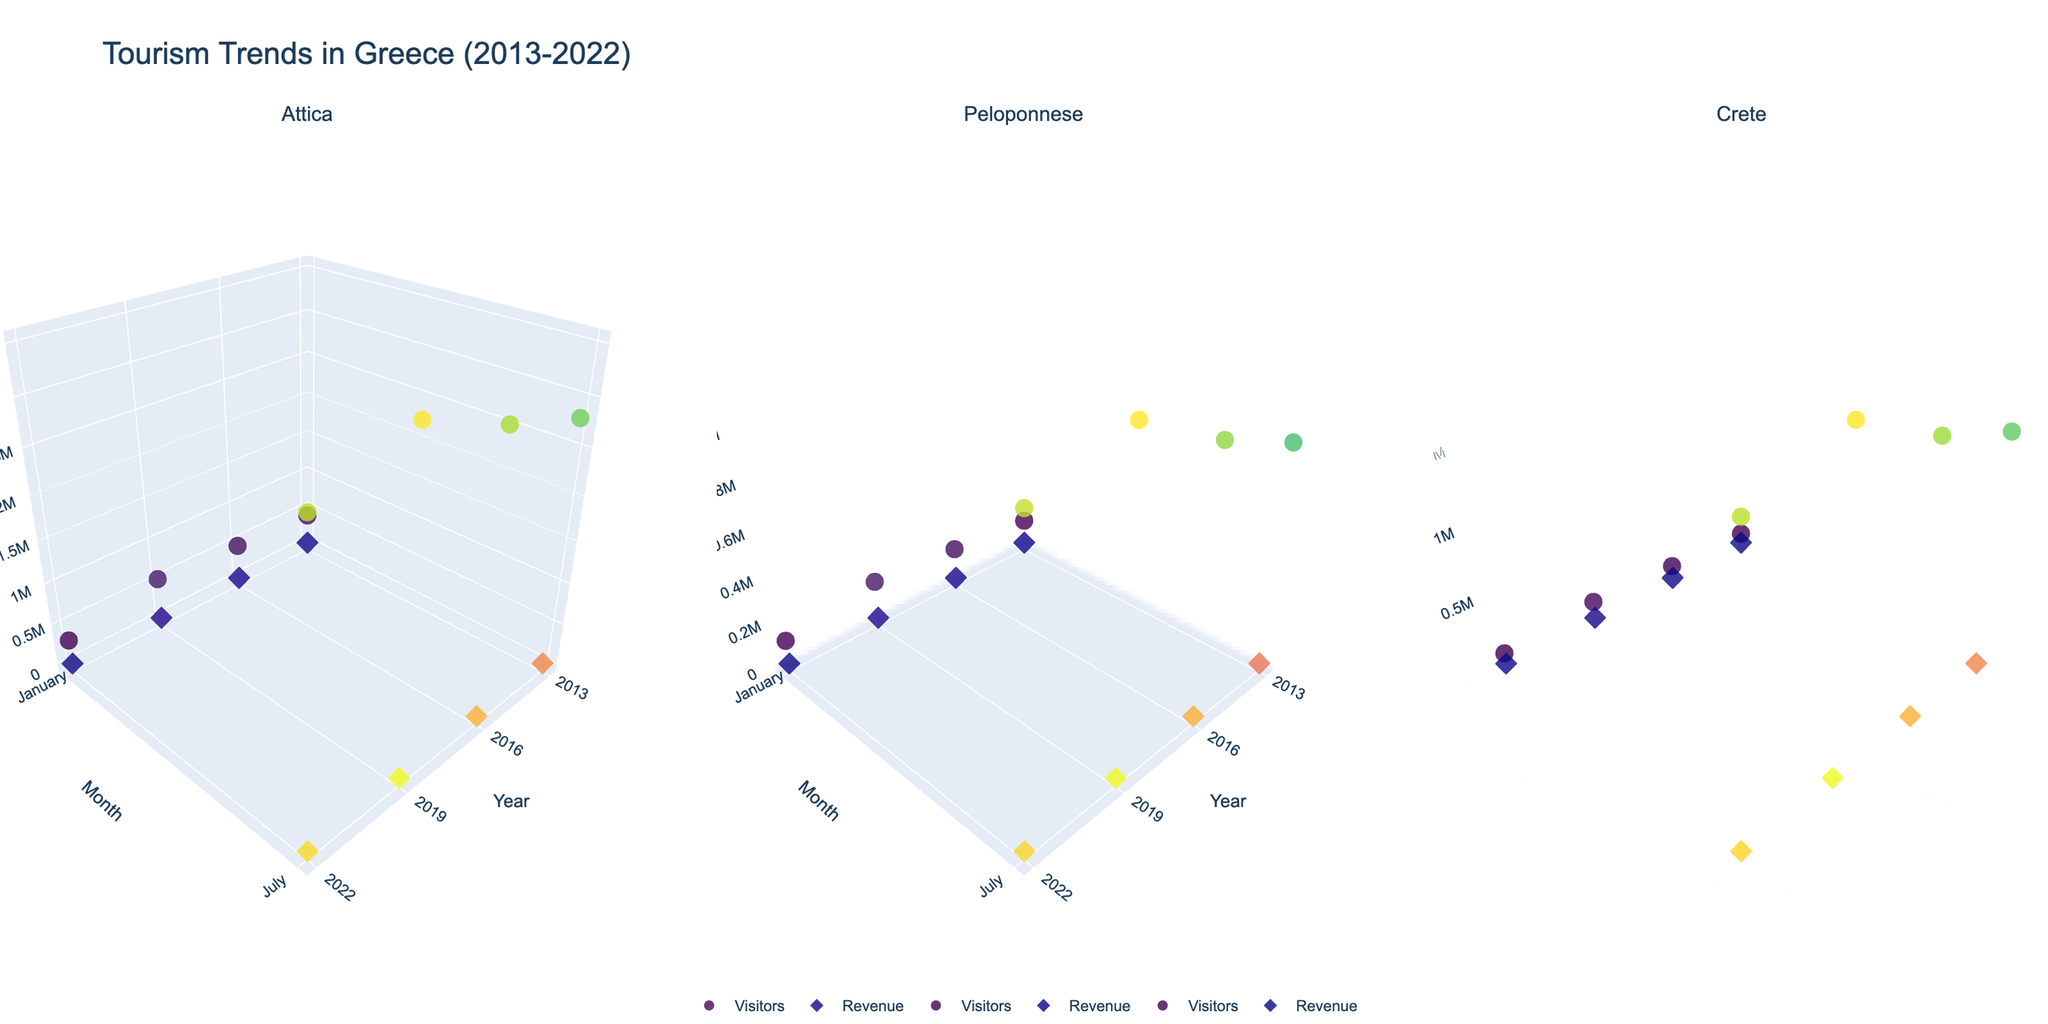Which year had the highest number of visitors in Attica in July? By looking at the 'Year' axis and 'Visitors' dimension on the sub-plot for Attica, the highest visitor numbers in July are observed in 2019 with 3,500,000 visitors.
Answer: 2019 Which region had the lowest number of visitors in January for the year 2013? Check the 'Visitors' data point for each region's January 2013 data. Crete had the lowest number of visitors, which is 80,000.
Answer: Crete What is the difference in revenue between Crete and Peloponnese in July 2019? Refer to the 'Revenue' dimension in the 3D scatter plots for Crete and Peloponnese and look at their values for July 2019. For Crete, it’s €1,700 million and for Peloponnese, it’s €850 million. The difference is €1,700 million - €850 million = €850 million.
Answer: €850 million In 2022, which month had a higher number of visitors for Attica, January or July? Compare the 'Visitors' data for Attica in 2022. January shows 300,000 visitors while July shows 3,200,000 visitors. Therefore, July had higher visitors.
Answer: July Did the number of visitors in Crete increase or decrease from January 2013 to January 2022? Check the 'Visitors' figures for Crete in January 2013 and January 2022. In January 2013, there were 80,000 visitors and in January 2022, there were also 80,000 visitors. Hence, there was no change.
Answer: No change Which year had the highest revenue in Peloponnese in July? Look at the 'Revenue' dimension for Peloponnese in July across all years in the subplot. The highest revenue is in July 2019 with €850 million.
Answer: 2019 What trend can be observed in Attica's January visitors from 2013 to 2019? Observe the plotting of the 'Visitors' data for Attica in January for the years 2013, 2016, and 2019. There is an increasing trend: 400,000 in 2013, 450,000 in 2016, and 520,000 in 2019.
Answer: Increasing trend How does the visitors' number in Peloponnese in July 2022 compare to that in July 2016? Compare the 'Visitors' values in Peloponnese for July in 2022 and 2016. In July 2016, it’s 1,100,000 and in July 2022, it’s 1,200,000. Hence, 2022 had more visitors by 100,000.
Answer: 2022 had more visitors 